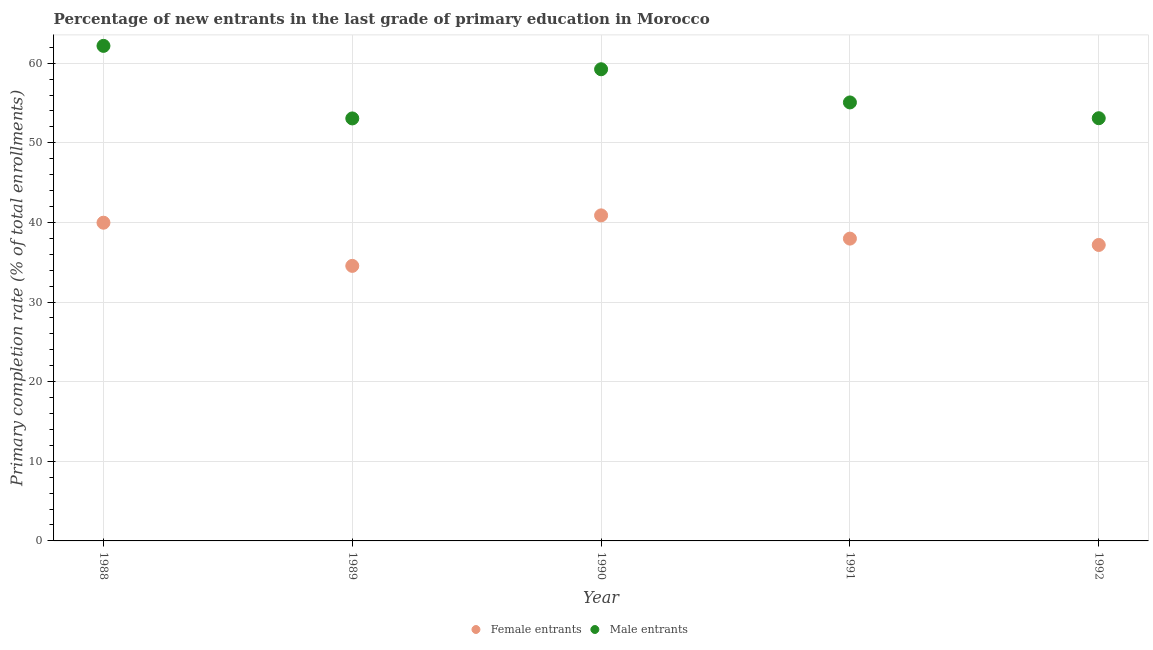How many different coloured dotlines are there?
Your answer should be compact. 2. Is the number of dotlines equal to the number of legend labels?
Provide a succinct answer. Yes. What is the primary completion rate of female entrants in 1990?
Provide a succinct answer. 40.89. Across all years, what is the maximum primary completion rate of male entrants?
Offer a very short reply. 62.17. Across all years, what is the minimum primary completion rate of male entrants?
Your answer should be very brief. 53.06. In which year was the primary completion rate of male entrants minimum?
Make the answer very short. 1989. What is the total primary completion rate of male entrants in the graph?
Give a very brief answer. 282.63. What is the difference between the primary completion rate of female entrants in 1989 and that in 1991?
Provide a succinct answer. -3.42. What is the difference between the primary completion rate of female entrants in 1991 and the primary completion rate of male entrants in 1992?
Offer a very short reply. -15.12. What is the average primary completion rate of female entrants per year?
Give a very brief answer. 38.11. In the year 1989, what is the difference between the primary completion rate of male entrants and primary completion rate of female entrants?
Your response must be concise. 18.52. What is the ratio of the primary completion rate of male entrants in 1989 to that in 1992?
Offer a terse response. 1. What is the difference between the highest and the second highest primary completion rate of male entrants?
Provide a succinct answer. 2.94. What is the difference between the highest and the lowest primary completion rate of male entrants?
Provide a short and direct response. 9.11. In how many years, is the primary completion rate of female entrants greater than the average primary completion rate of female entrants taken over all years?
Offer a terse response. 2. Does the primary completion rate of male entrants monotonically increase over the years?
Ensure brevity in your answer.  No. Is the primary completion rate of male entrants strictly greater than the primary completion rate of female entrants over the years?
Your response must be concise. Yes. How many dotlines are there?
Your answer should be compact. 2. How many years are there in the graph?
Provide a short and direct response. 5. What is the difference between two consecutive major ticks on the Y-axis?
Your answer should be compact. 10. How are the legend labels stacked?
Give a very brief answer. Horizontal. What is the title of the graph?
Provide a short and direct response. Percentage of new entrants in the last grade of primary education in Morocco. What is the label or title of the Y-axis?
Your answer should be very brief. Primary completion rate (% of total enrollments). What is the Primary completion rate (% of total enrollments) of Female entrants in 1988?
Keep it short and to the point. 39.96. What is the Primary completion rate (% of total enrollments) in Male entrants in 1988?
Make the answer very short. 62.17. What is the Primary completion rate (% of total enrollments) of Female entrants in 1989?
Provide a succinct answer. 34.54. What is the Primary completion rate (% of total enrollments) of Male entrants in 1989?
Your answer should be compact. 53.06. What is the Primary completion rate (% of total enrollments) of Female entrants in 1990?
Provide a short and direct response. 40.89. What is the Primary completion rate (% of total enrollments) in Male entrants in 1990?
Make the answer very short. 59.24. What is the Primary completion rate (% of total enrollments) of Female entrants in 1991?
Your answer should be very brief. 37.97. What is the Primary completion rate (% of total enrollments) of Male entrants in 1991?
Your answer should be compact. 55.07. What is the Primary completion rate (% of total enrollments) in Female entrants in 1992?
Provide a succinct answer. 37.17. What is the Primary completion rate (% of total enrollments) in Male entrants in 1992?
Ensure brevity in your answer.  53.09. Across all years, what is the maximum Primary completion rate (% of total enrollments) of Female entrants?
Your answer should be compact. 40.89. Across all years, what is the maximum Primary completion rate (% of total enrollments) of Male entrants?
Provide a short and direct response. 62.17. Across all years, what is the minimum Primary completion rate (% of total enrollments) of Female entrants?
Offer a very short reply. 34.54. Across all years, what is the minimum Primary completion rate (% of total enrollments) in Male entrants?
Your response must be concise. 53.06. What is the total Primary completion rate (% of total enrollments) of Female entrants in the graph?
Your answer should be compact. 190.53. What is the total Primary completion rate (% of total enrollments) of Male entrants in the graph?
Your answer should be very brief. 282.63. What is the difference between the Primary completion rate (% of total enrollments) in Female entrants in 1988 and that in 1989?
Your response must be concise. 5.42. What is the difference between the Primary completion rate (% of total enrollments) of Male entrants in 1988 and that in 1989?
Provide a short and direct response. 9.11. What is the difference between the Primary completion rate (% of total enrollments) of Female entrants in 1988 and that in 1990?
Your response must be concise. -0.92. What is the difference between the Primary completion rate (% of total enrollments) of Male entrants in 1988 and that in 1990?
Provide a succinct answer. 2.94. What is the difference between the Primary completion rate (% of total enrollments) in Female entrants in 1988 and that in 1991?
Keep it short and to the point. 2. What is the difference between the Primary completion rate (% of total enrollments) in Male entrants in 1988 and that in 1991?
Your response must be concise. 7.1. What is the difference between the Primary completion rate (% of total enrollments) of Female entrants in 1988 and that in 1992?
Offer a very short reply. 2.79. What is the difference between the Primary completion rate (% of total enrollments) of Male entrants in 1988 and that in 1992?
Your response must be concise. 9.09. What is the difference between the Primary completion rate (% of total enrollments) in Female entrants in 1989 and that in 1990?
Provide a succinct answer. -6.34. What is the difference between the Primary completion rate (% of total enrollments) in Male entrants in 1989 and that in 1990?
Make the answer very short. -6.18. What is the difference between the Primary completion rate (% of total enrollments) in Female entrants in 1989 and that in 1991?
Ensure brevity in your answer.  -3.42. What is the difference between the Primary completion rate (% of total enrollments) of Male entrants in 1989 and that in 1991?
Your answer should be very brief. -2.01. What is the difference between the Primary completion rate (% of total enrollments) in Female entrants in 1989 and that in 1992?
Ensure brevity in your answer.  -2.63. What is the difference between the Primary completion rate (% of total enrollments) of Male entrants in 1989 and that in 1992?
Provide a succinct answer. -0.03. What is the difference between the Primary completion rate (% of total enrollments) of Female entrants in 1990 and that in 1991?
Offer a terse response. 2.92. What is the difference between the Primary completion rate (% of total enrollments) in Male entrants in 1990 and that in 1991?
Offer a very short reply. 4.17. What is the difference between the Primary completion rate (% of total enrollments) of Female entrants in 1990 and that in 1992?
Your answer should be very brief. 3.71. What is the difference between the Primary completion rate (% of total enrollments) of Male entrants in 1990 and that in 1992?
Your answer should be compact. 6.15. What is the difference between the Primary completion rate (% of total enrollments) of Female entrants in 1991 and that in 1992?
Provide a succinct answer. 0.8. What is the difference between the Primary completion rate (% of total enrollments) of Male entrants in 1991 and that in 1992?
Offer a very short reply. 1.98. What is the difference between the Primary completion rate (% of total enrollments) in Female entrants in 1988 and the Primary completion rate (% of total enrollments) in Male entrants in 1989?
Provide a succinct answer. -13.1. What is the difference between the Primary completion rate (% of total enrollments) in Female entrants in 1988 and the Primary completion rate (% of total enrollments) in Male entrants in 1990?
Give a very brief answer. -19.27. What is the difference between the Primary completion rate (% of total enrollments) in Female entrants in 1988 and the Primary completion rate (% of total enrollments) in Male entrants in 1991?
Keep it short and to the point. -15.11. What is the difference between the Primary completion rate (% of total enrollments) in Female entrants in 1988 and the Primary completion rate (% of total enrollments) in Male entrants in 1992?
Your answer should be very brief. -13.12. What is the difference between the Primary completion rate (% of total enrollments) in Female entrants in 1989 and the Primary completion rate (% of total enrollments) in Male entrants in 1990?
Give a very brief answer. -24.69. What is the difference between the Primary completion rate (% of total enrollments) in Female entrants in 1989 and the Primary completion rate (% of total enrollments) in Male entrants in 1991?
Ensure brevity in your answer.  -20.53. What is the difference between the Primary completion rate (% of total enrollments) of Female entrants in 1989 and the Primary completion rate (% of total enrollments) of Male entrants in 1992?
Offer a terse response. -18.54. What is the difference between the Primary completion rate (% of total enrollments) of Female entrants in 1990 and the Primary completion rate (% of total enrollments) of Male entrants in 1991?
Your answer should be very brief. -14.18. What is the difference between the Primary completion rate (% of total enrollments) of Female entrants in 1990 and the Primary completion rate (% of total enrollments) of Male entrants in 1992?
Offer a terse response. -12.2. What is the difference between the Primary completion rate (% of total enrollments) in Female entrants in 1991 and the Primary completion rate (% of total enrollments) in Male entrants in 1992?
Provide a succinct answer. -15.12. What is the average Primary completion rate (% of total enrollments) of Female entrants per year?
Offer a very short reply. 38.11. What is the average Primary completion rate (% of total enrollments) in Male entrants per year?
Offer a terse response. 56.53. In the year 1988, what is the difference between the Primary completion rate (% of total enrollments) of Female entrants and Primary completion rate (% of total enrollments) of Male entrants?
Offer a terse response. -22.21. In the year 1989, what is the difference between the Primary completion rate (% of total enrollments) in Female entrants and Primary completion rate (% of total enrollments) in Male entrants?
Keep it short and to the point. -18.52. In the year 1990, what is the difference between the Primary completion rate (% of total enrollments) in Female entrants and Primary completion rate (% of total enrollments) in Male entrants?
Give a very brief answer. -18.35. In the year 1991, what is the difference between the Primary completion rate (% of total enrollments) of Female entrants and Primary completion rate (% of total enrollments) of Male entrants?
Provide a succinct answer. -17.1. In the year 1992, what is the difference between the Primary completion rate (% of total enrollments) in Female entrants and Primary completion rate (% of total enrollments) in Male entrants?
Offer a terse response. -15.92. What is the ratio of the Primary completion rate (% of total enrollments) in Female entrants in 1988 to that in 1989?
Make the answer very short. 1.16. What is the ratio of the Primary completion rate (% of total enrollments) of Male entrants in 1988 to that in 1989?
Offer a terse response. 1.17. What is the ratio of the Primary completion rate (% of total enrollments) in Female entrants in 1988 to that in 1990?
Offer a very short reply. 0.98. What is the ratio of the Primary completion rate (% of total enrollments) in Male entrants in 1988 to that in 1990?
Your answer should be compact. 1.05. What is the ratio of the Primary completion rate (% of total enrollments) in Female entrants in 1988 to that in 1991?
Your answer should be compact. 1.05. What is the ratio of the Primary completion rate (% of total enrollments) of Male entrants in 1988 to that in 1991?
Your answer should be compact. 1.13. What is the ratio of the Primary completion rate (% of total enrollments) of Female entrants in 1988 to that in 1992?
Provide a short and direct response. 1.08. What is the ratio of the Primary completion rate (% of total enrollments) in Male entrants in 1988 to that in 1992?
Ensure brevity in your answer.  1.17. What is the ratio of the Primary completion rate (% of total enrollments) in Female entrants in 1989 to that in 1990?
Provide a short and direct response. 0.84. What is the ratio of the Primary completion rate (% of total enrollments) in Male entrants in 1989 to that in 1990?
Your answer should be compact. 0.9. What is the ratio of the Primary completion rate (% of total enrollments) of Female entrants in 1989 to that in 1991?
Your answer should be compact. 0.91. What is the ratio of the Primary completion rate (% of total enrollments) of Male entrants in 1989 to that in 1991?
Your response must be concise. 0.96. What is the ratio of the Primary completion rate (% of total enrollments) of Female entrants in 1989 to that in 1992?
Keep it short and to the point. 0.93. What is the ratio of the Primary completion rate (% of total enrollments) of Male entrants in 1989 to that in 1992?
Keep it short and to the point. 1. What is the ratio of the Primary completion rate (% of total enrollments) in Female entrants in 1990 to that in 1991?
Your answer should be compact. 1.08. What is the ratio of the Primary completion rate (% of total enrollments) of Male entrants in 1990 to that in 1991?
Keep it short and to the point. 1.08. What is the ratio of the Primary completion rate (% of total enrollments) in Female entrants in 1990 to that in 1992?
Ensure brevity in your answer.  1.1. What is the ratio of the Primary completion rate (% of total enrollments) in Male entrants in 1990 to that in 1992?
Your answer should be very brief. 1.12. What is the ratio of the Primary completion rate (% of total enrollments) of Female entrants in 1991 to that in 1992?
Provide a short and direct response. 1.02. What is the ratio of the Primary completion rate (% of total enrollments) in Male entrants in 1991 to that in 1992?
Keep it short and to the point. 1.04. What is the difference between the highest and the second highest Primary completion rate (% of total enrollments) in Female entrants?
Your answer should be compact. 0.92. What is the difference between the highest and the second highest Primary completion rate (% of total enrollments) in Male entrants?
Keep it short and to the point. 2.94. What is the difference between the highest and the lowest Primary completion rate (% of total enrollments) of Female entrants?
Ensure brevity in your answer.  6.34. What is the difference between the highest and the lowest Primary completion rate (% of total enrollments) of Male entrants?
Offer a terse response. 9.11. 